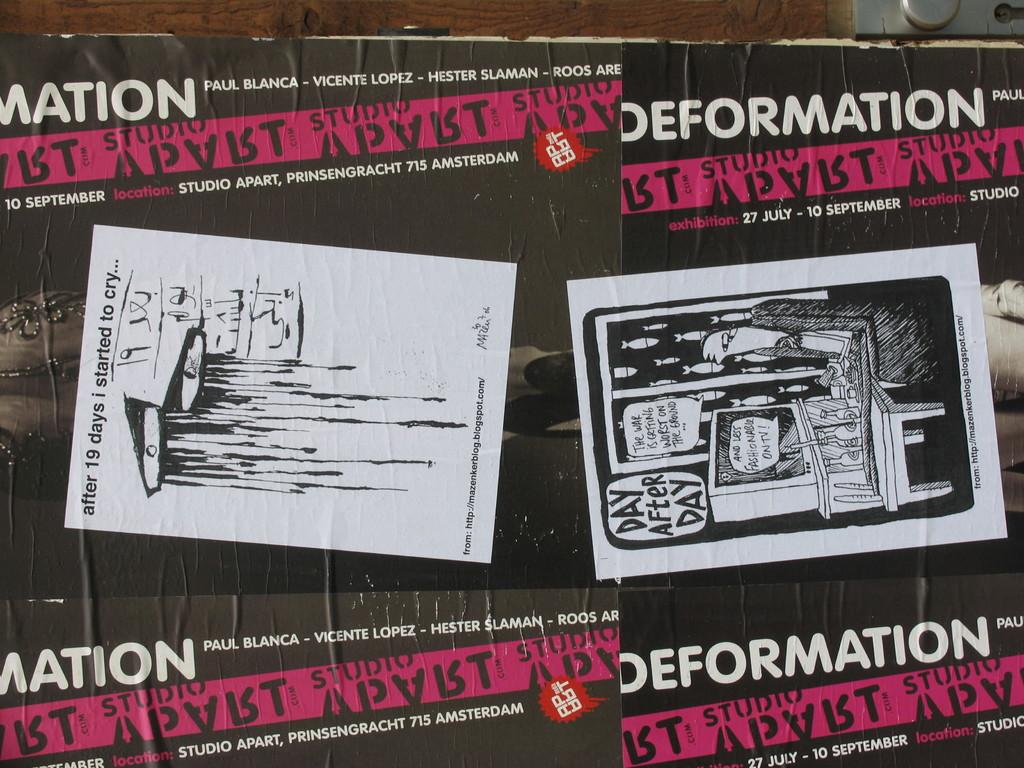<image>
Relay a brief, clear account of the picture shown. Poster advertising Defamation art event for September 10th. 